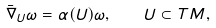<formula> <loc_0><loc_0><loc_500><loc_500>\bar { \nabla } _ { U } \omega = \alpha ( U ) \omega , \quad U \subset T M ,</formula> 